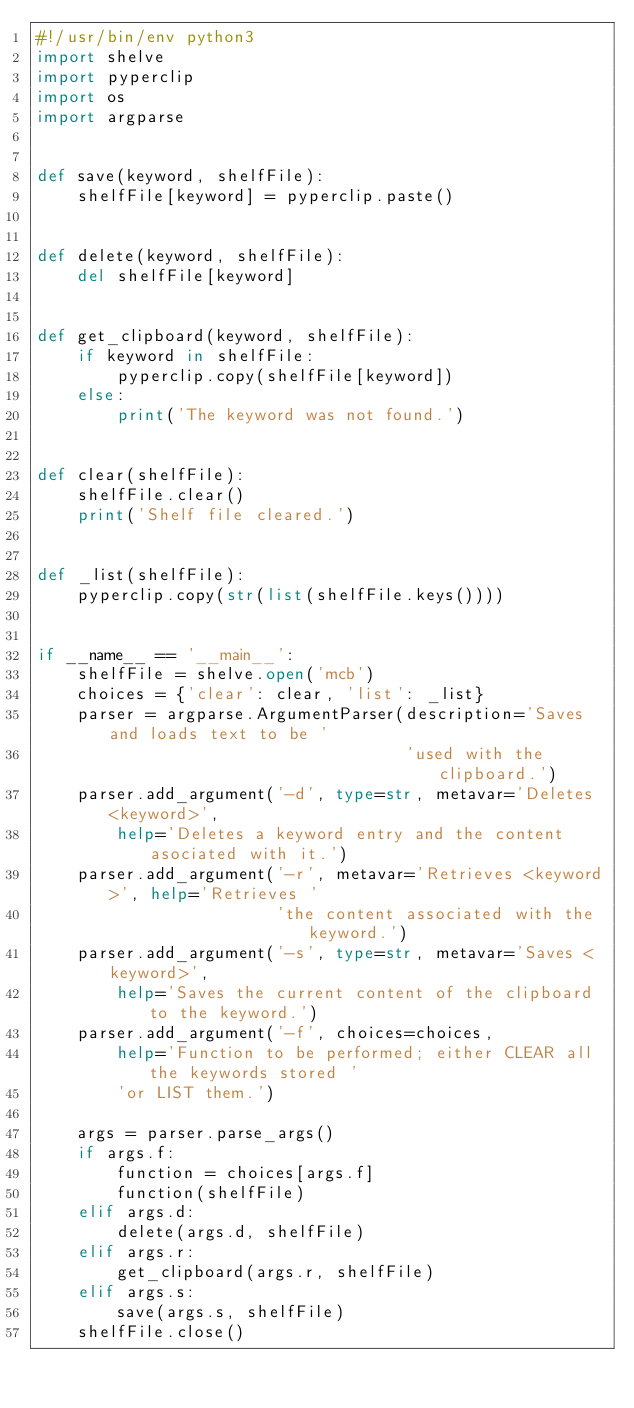Convert code to text. <code><loc_0><loc_0><loc_500><loc_500><_Python_>#!/usr/bin/env python3
import shelve
import pyperclip
import os
import argparse


def save(keyword, shelfFile):
    shelfFile[keyword] = pyperclip.paste()


def delete(keyword, shelfFile):
    del shelfFile[keyword]


def get_clipboard(keyword, shelfFile):
    if keyword in shelfFile:
        pyperclip.copy(shelfFile[keyword])
    else:
        print('The keyword was not found.')


def clear(shelfFile):
    shelfFile.clear()
    print('Shelf file cleared.')


def _list(shelfFile):
    pyperclip.copy(str(list(shelfFile.keys())))


if __name__ == '__main__':
    shelfFile = shelve.open('mcb')
    choices = {'clear': clear, 'list': _list}
    parser = argparse.ArgumentParser(description='Saves and loads text to be '
                                     'used with the clipboard.')
    parser.add_argument('-d', type=str, metavar='Deletes <keyword>',
        help='Deletes a keyword entry and the content asociated with it.')
    parser.add_argument('-r', metavar='Retrieves <keyword>', help='Retrieves '
                        'the content associated with the keyword.')
    parser.add_argument('-s', type=str, metavar='Saves <keyword>',
        help='Saves the current content of the clipboard to the keyword.')
    parser.add_argument('-f', choices=choices,
        help='Function to be performed; either CLEAR all the keywords stored '
        'or LIST them.')

    args = parser.parse_args()
    if args.f:
        function = choices[args.f]
        function(shelfFile)
    elif args.d:
        delete(args.d, shelfFile)
    elif args.r:
        get_clipboard(args.r, shelfFile)
    elif args.s:
        save(args.s, shelfFile)
    shelfFile.close()
</code> 